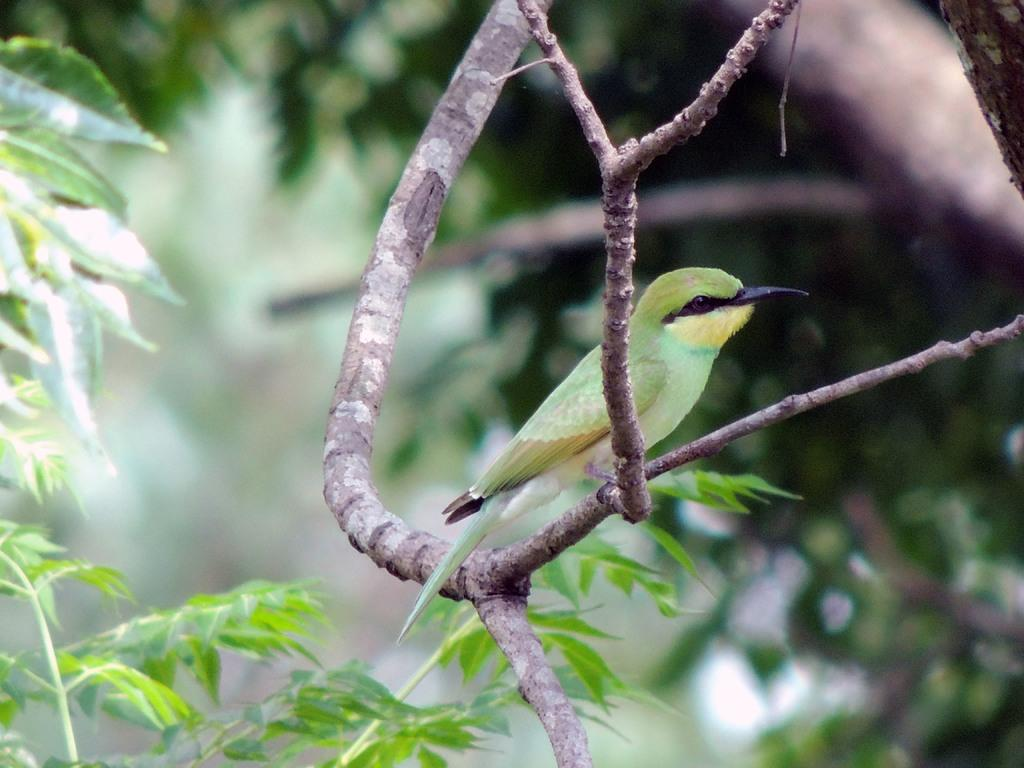What type of animal can be seen in the image? There is a bird in the image. Where is the bird located in the image? The bird is sitting on a branch. What is the branch attached to? The branch belongs to a tree. What can be seen in the background of the image? There are trees in the background of the image. What type of environment might the image have been taken in? The image may have been taken in a forest. What is the bird's opinion on friction in the image? There is no indication of the bird's opinion on friction in the image, as it is a visual representation and does not convey opinions or thoughts. 